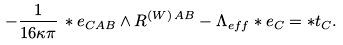Convert formula to latex. <formula><loc_0><loc_0><loc_500><loc_500>- \frac { 1 } { 1 6 \kappa \pi } \, \ast e _ { C A B } \wedge R ^ { ( W ) \, A B } - \Lambda _ { e f f } \ast e _ { C } = \ast t _ { C } .</formula> 